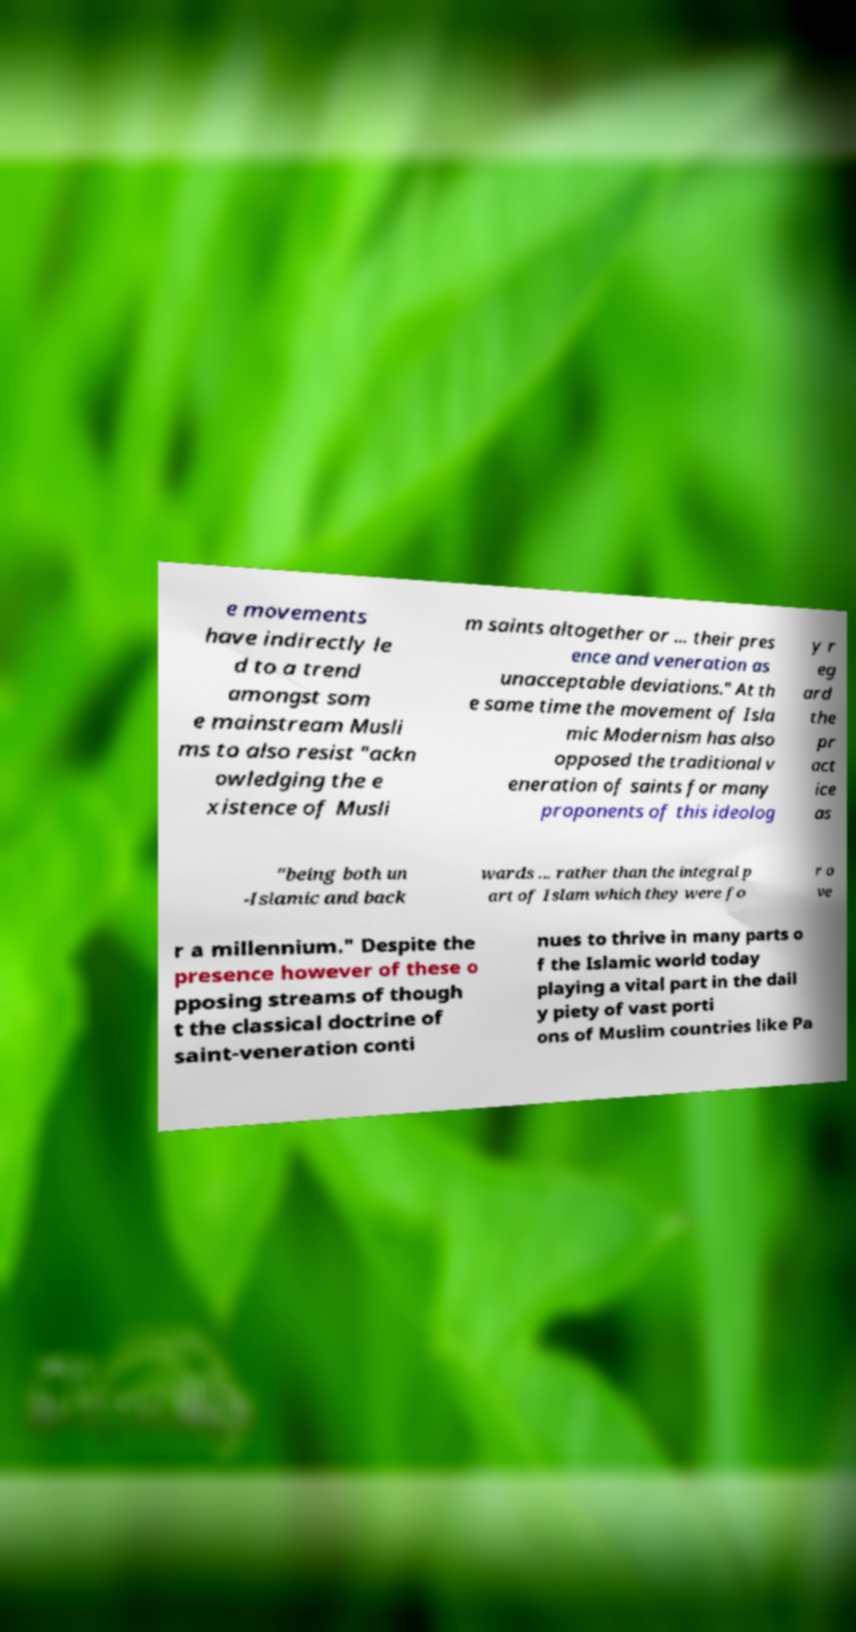Could you extract and type out the text from this image? e movements have indirectly le d to a trend amongst som e mainstream Musli ms to also resist "ackn owledging the e xistence of Musli m saints altogether or ... their pres ence and veneration as unacceptable deviations." At th e same time the movement of Isla mic Modernism has also opposed the traditional v eneration of saints for many proponents of this ideolog y r eg ard the pr act ice as "being both un -Islamic and back wards ... rather than the integral p art of Islam which they were fo r o ve r a millennium." Despite the presence however of these o pposing streams of though t the classical doctrine of saint-veneration conti nues to thrive in many parts o f the Islamic world today playing a vital part in the dail y piety of vast porti ons of Muslim countries like Pa 